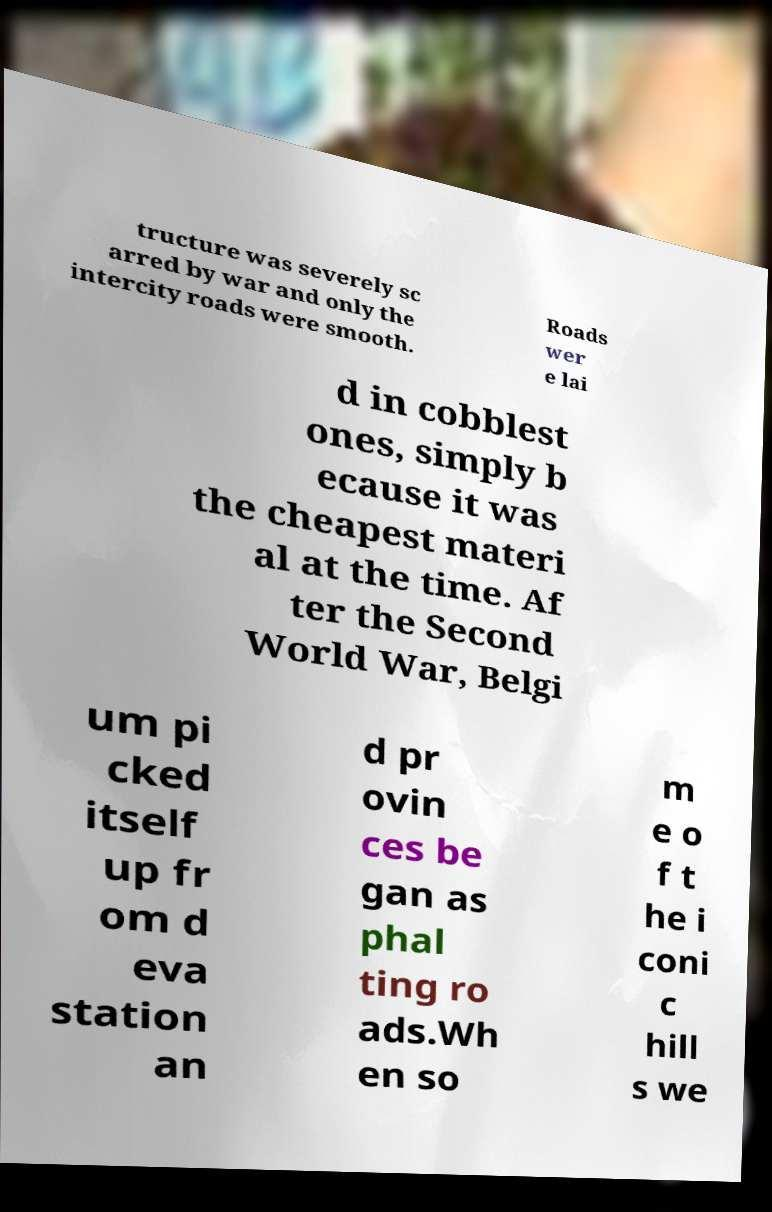Could you extract and type out the text from this image? tructure was severely sc arred by war and only the intercity roads were smooth. Roads wer e lai d in cobblest ones, simply b ecause it was the cheapest materi al at the time. Af ter the Second World War, Belgi um pi cked itself up fr om d eva station an d pr ovin ces be gan as phal ting ro ads.Wh en so m e o f t he i coni c hill s we 